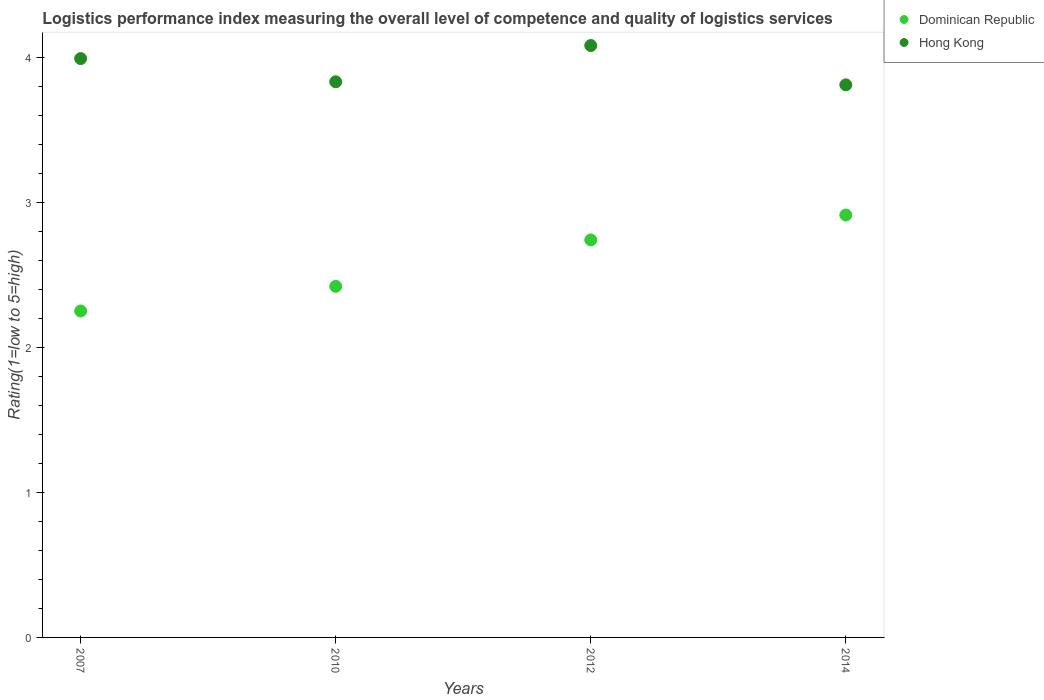How many different coloured dotlines are there?
Provide a short and direct response. 2. What is the Logistic performance index in Dominican Republic in 2010?
Your response must be concise. 2.42. Across all years, what is the maximum Logistic performance index in Dominican Republic?
Your answer should be compact. 2.91. Across all years, what is the minimum Logistic performance index in Dominican Republic?
Provide a succinct answer. 2.25. In which year was the Logistic performance index in Dominican Republic minimum?
Your answer should be very brief. 2007. What is the total Logistic performance index in Hong Kong in the graph?
Your answer should be very brief. 15.71. What is the difference between the Logistic performance index in Hong Kong in 2010 and that in 2014?
Your answer should be compact. 0.02. What is the difference between the Logistic performance index in Dominican Republic in 2010 and the Logistic performance index in Hong Kong in 2012?
Give a very brief answer. -1.66. What is the average Logistic performance index in Hong Kong per year?
Your answer should be compact. 3.93. In the year 2012, what is the difference between the Logistic performance index in Hong Kong and Logistic performance index in Dominican Republic?
Give a very brief answer. 1.34. What is the ratio of the Logistic performance index in Hong Kong in 2007 to that in 2012?
Offer a terse response. 0.98. Is the Logistic performance index in Dominican Republic in 2007 less than that in 2014?
Give a very brief answer. Yes. Is the difference between the Logistic performance index in Hong Kong in 2010 and 2012 greater than the difference between the Logistic performance index in Dominican Republic in 2010 and 2012?
Keep it short and to the point. Yes. What is the difference between the highest and the second highest Logistic performance index in Hong Kong?
Your response must be concise. 0.09. What is the difference between the highest and the lowest Logistic performance index in Dominican Republic?
Offer a very short reply. 0.66. Does the Logistic performance index in Hong Kong monotonically increase over the years?
Give a very brief answer. No. Is the Logistic performance index in Dominican Republic strictly less than the Logistic performance index in Hong Kong over the years?
Provide a short and direct response. Yes. How many dotlines are there?
Your response must be concise. 2. How many years are there in the graph?
Keep it short and to the point. 4. What is the difference between two consecutive major ticks on the Y-axis?
Your answer should be very brief. 1. Are the values on the major ticks of Y-axis written in scientific E-notation?
Keep it short and to the point. No. Does the graph contain any zero values?
Give a very brief answer. No. How are the legend labels stacked?
Provide a short and direct response. Vertical. What is the title of the graph?
Your answer should be compact. Logistics performance index measuring the overall level of competence and quality of logistics services. Does "Middle income" appear as one of the legend labels in the graph?
Provide a succinct answer. No. What is the label or title of the Y-axis?
Ensure brevity in your answer.  Rating(1=low to 5=high). What is the Rating(1=low to 5=high) in Dominican Republic in 2007?
Offer a terse response. 2.25. What is the Rating(1=low to 5=high) of Hong Kong in 2007?
Provide a succinct answer. 3.99. What is the Rating(1=low to 5=high) of Dominican Republic in 2010?
Make the answer very short. 2.42. What is the Rating(1=low to 5=high) in Hong Kong in 2010?
Offer a very short reply. 3.83. What is the Rating(1=low to 5=high) of Dominican Republic in 2012?
Offer a terse response. 2.74. What is the Rating(1=low to 5=high) of Hong Kong in 2012?
Make the answer very short. 4.08. What is the Rating(1=low to 5=high) of Dominican Republic in 2014?
Keep it short and to the point. 2.91. What is the Rating(1=low to 5=high) of Hong Kong in 2014?
Offer a terse response. 3.81. Across all years, what is the maximum Rating(1=low to 5=high) of Dominican Republic?
Keep it short and to the point. 2.91. Across all years, what is the maximum Rating(1=low to 5=high) of Hong Kong?
Give a very brief answer. 4.08. Across all years, what is the minimum Rating(1=low to 5=high) in Dominican Republic?
Give a very brief answer. 2.25. Across all years, what is the minimum Rating(1=low to 5=high) in Hong Kong?
Your response must be concise. 3.81. What is the total Rating(1=low to 5=high) of Dominican Republic in the graph?
Provide a short and direct response. 10.32. What is the total Rating(1=low to 5=high) of Hong Kong in the graph?
Give a very brief answer. 15.71. What is the difference between the Rating(1=low to 5=high) in Dominican Republic in 2007 and that in 2010?
Give a very brief answer. -0.17. What is the difference between the Rating(1=low to 5=high) in Hong Kong in 2007 and that in 2010?
Your response must be concise. 0.16. What is the difference between the Rating(1=low to 5=high) in Dominican Republic in 2007 and that in 2012?
Your answer should be very brief. -0.49. What is the difference between the Rating(1=low to 5=high) of Hong Kong in 2007 and that in 2012?
Offer a very short reply. -0.09. What is the difference between the Rating(1=low to 5=high) in Dominican Republic in 2007 and that in 2014?
Offer a very short reply. -0.66. What is the difference between the Rating(1=low to 5=high) in Hong Kong in 2007 and that in 2014?
Provide a short and direct response. 0.18. What is the difference between the Rating(1=low to 5=high) of Dominican Republic in 2010 and that in 2012?
Give a very brief answer. -0.32. What is the difference between the Rating(1=low to 5=high) of Dominican Republic in 2010 and that in 2014?
Offer a very short reply. -0.49. What is the difference between the Rating(1=low to 5=high) in Hong Kong in 2010 and that in 2014?
Give a very brief answer. 0.02. What is the difference between the Rating(1=low to 5=high) in Dominican Republic in 2012 and that in 2014?
Ensure brevity in your answer.  -0.17. What is the difference between the Rating(1=low to 5=high) in Hong Kong in 2012 and that in 2014?
Your answer should be very brief. 0.27. What is the difference between the Rating(1=low to 5=high) in Dominican Republic in 2007 and the Rating(1=low to 5=high) in Hong Kong in 2010?
Your response must be concise. -1.58. What is the difference between the Rating(1=low to 5=high) of Dominican Republic in 2007 and the Rating(1=low to 5=high) of Hong Kong in 2012?
Your response must be concise. -1.83. What is the difference between the Rating(1=low to 5=high) in Dominican Republic in 2007 and the Rating(1=low to 5=high) in Hong Kong in 2014?
Give a very brief answer. -1.56. What is the difference between the Rating(1=low to 5=high) of Dominican Republic in 2010 and the Rating(1=low to 5=high) of Hong Kong in 2012?
Offer a terse response. -1.66. What is the difference between the Rating(1=low to 5=high) of Dominican Republic in 2010 and the Rating(1=low to 5=high) of Hong Kong in 2014?
Keep it short and to the point. -1.39. What is the difference between the Rating(1=low to 5=high) in Dominican Republic in 2012 and the Rating(1=low to 5=high) in Hong Kong in 2014?
Offer a very short reply. -1.07. What is the average Rating(1=low to 5=high) of Dominican Republic per year?
Provide a short and direct response. 2.58. What is the average Rating(1=low to 5=high) of Hong Kong per year?
Give a very brief answer. 3.93. In the year 2007, what is the difference between the Rating(1=low to 5=high) in Dominican Republic and Rating(1=low to 5=high) in Hong Kong?
Provide a short and direct response. -1.74. In the year 2010, what is the difference between the Rating(1=low to 5=high) of Dominican Republic and Rating(1=low to 5=high) of Hong Kong?
Give a very brief answer. -1.41. In the year 2012, what is the difference between the Rating(1=low to 5=high) in Dominican Republic and Rating(1=low to 5=high) in Hong Kong?
Keep it short and to the point. -1.34. In the year 2014, what is the difference between the Rating(1=low to 5=high) in Dominican Republic and Rating(1=low to 5=high) in Hong Kong?
Provide a succinct answer. -0.9. What is the ratio of the Rating(1=low to 5=high) in Dominican Republic in 2007 to that in 2010?
Provide a short and direct response. 0.93. What is the ratio of the Rating(1=low to 5=high) of Hong Kong in 2007 to that in 2010?
Keep it short and to the point. 1.04. What is the ratio of the Rating(1=low to 5=high) in Dominican Republic in 2007 to that in 2012?
Make the answer very short. 0.82. What is the ratio of the Rating(1=low to 5=high) of Hong Kong in 2007 to that in 2012?
Provide a succinct answer. 0.98. What is the ratio of the Rating(1=low to 5=high) of Dominican Republic in 2007 to that in 2014?
Provide a short and direct response. 0.77. What is the ratio of the Rating(1=low to 5=high) in Hong Kong in 2007 to that in 2014?
Ensure brevity in your answer.  1.05. What is the ratio of the Rating(1=low to 5=high) in Dominican Republic in 2010 to that in 2012?
Keep it short and to the point. 0.88. What is the ratio of the Rating(1=low to 5=high) in Hong Kong in 2010 to that in 2012?
Your response must be concise. 0.94. What is the ratio of the Rating(1=low to 5=high) in Dominican Republic in 2010 to that in 2014?
Offer a very short reply. 0.83. What is the ratio of the Rating(1=low to 5=high) of Dominican Republic in 2012 to that in 2014?
Keep it short and to the point. 0.94. What is the ratio of the Rating(1=low to 5=high) in Hong Kong in 2012 to that in 2014?
Offer a very short reply. 1.07. What is the difference between the highest and the second highest Rating(1=low to 5=high) in Dominican Republic?
Ensure brevity in your answer.  0.17. What is the difference between the highest and the second highest Rating(1=low to 5=high) in Hong Kong?
Your answer should be compact. 0.09. What is the difference between the highest and the lowest Rating(1=low to 5=high) in Dominican Republic?
Provide a succinct answer. 0.66. What is the difference between the highest and the lowest Rating(1=low to 5=high) of Hong Kong?
Provide a short and direct response. 0.27. 